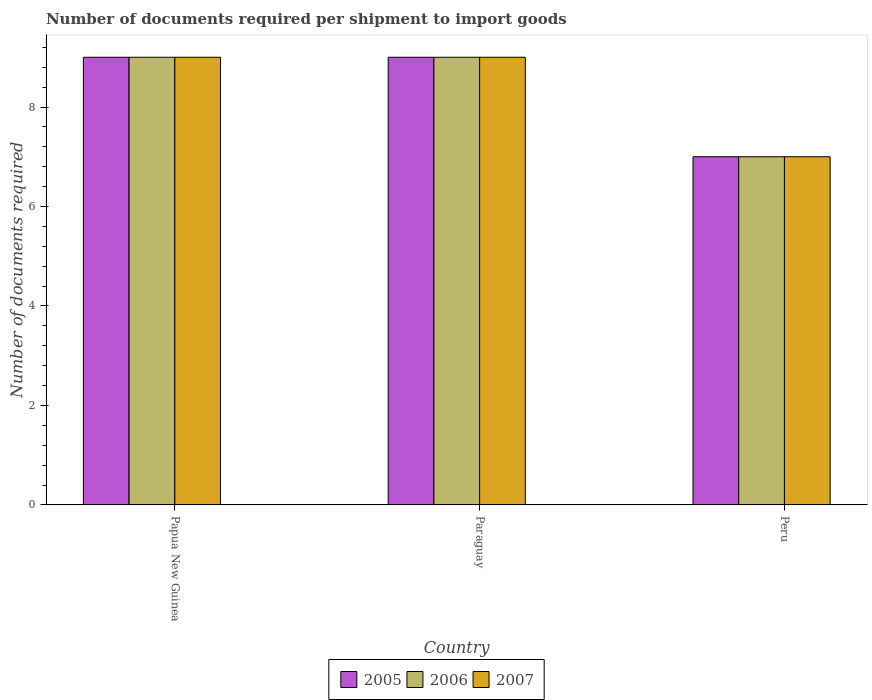Are the number of bars per tick equal to the number of legend labels?
Give a very brief answer. Yes. How many bars are there on the 3rd tick from the left?
Provide a short and direct response. 3. In how many cases, is the number of bars for a given country not equal to the number of legend labels?
Your answer should be very brief. 0. What is the number of documents required per shipment to import goods in 2006 in Papua New Guinea?
Ensure brevity in your answer.  9. Across all countries, what is the maximum number of documents required per shipment to import goods in 2007?
Give a very brief answer. 9. In which country was the number of documents required per shipment to import goods in 2006 maximum?
Make the answer very short. Papua New Guinea. What is the difference between the number of documents required per shipment to import goods in 2007 in Paraguay and that in Peru?
Offer a very short reply. 2. What is the average number of documents required per shipment to import goods in 2006 per country?
Ensure brevity in your answer.  8.33. What is the difference between the number of documents required per shipment to import goods of/in 2006 and number of documents required per shipment to import goods of/in 2007 in Paraguay?
Ensure brevity in your answer.  0. What is the ratio of the number of documents required per shipment to import goods in 2006 in Paraguay to that in Peru?
Provide a short and direct response. 1.29. What is the difference between the highest and the second highest number of documents required per shipment to import goods in 2005?
Keep it short and to the point. 2. What is the difference between the highest and the lowest number of documents required per shipment to import goods in 2007?
Your answer should be compact. 2. What does the 2nd bar from the left in Peru represents?
Your answer should be compact. 2006. What does the 2nd bar from the right in Papua New Guinea represents?
Keep it short and to the point. 2006. Is it the case that in every country, the sum of the number of documents required per shipment to import goods in 2007 and number of documents required per shipment to import goods in 2006 is greater than the number of documents required per shipment to import goods in 2005?
Keep it short and to the point. Yes. How many bars are there?
Provide a short and direct response. 9. How many countries are there in the graph?
Keep it short and to the point. 3. Does the graph contain any zero values?
Keep it short and to the point. No. Does the graph contain grids?
Your response must be concise. No. What is the title of the graph?
Ensure brevity in your answer.  Number of documents required per shipment to import goods. Does "1984" appear as one of the legend labels in the graph?
Your response must be concise. No. What is the label or title of the X-axis?
Make the answer very short. Country. What is the label or title of the Y-axis?
Your response must be concise. Number of documents required. What is the Number of documents required in 2006 in Paraguay?
Your answer should be very brief. 9. What is the Number of documents required in 2007 in Paraguay?
Your answer should be very brief. 9. What is the Number of documents required in 2005 in Peru?
Keep it short and to the point. 7. What is the Number of documents required of 2006 in Peru?
Your answer should be compact. 7. Across all countries, what is the maximum Number of documents required in 2005?
Keep it short and to the point. 9. Across all countries, what is the maximum Number of documents required in 2006?
Offer a terse response. 9. Across all countries, what is the maximum Number of documents required of 2007?
Keep it short and to the point. 9. Across all countries, what is the minimum Number of documents required of 2005?
Keep it short and to the point. 7. What is the total Number of documents required in 2005 in the graph?
Your answer should be compact. 25. What is the total Number of documents required in 2006 in the graph?
Your answer should be compact. 25. What is the difference between the Number of documents required of 2005 in Papua New Guinea and that in Paraguay?
Ensure brevity in your answer.  0. What is the difference between the Number of documents required in 2007 in Papua New Guinea and that in Paraguay?
Provide a succinct answer. 0. What is the difference between the Number of documents required in 2005 in Papua New Guinea and that in Peru?
Your answer should be very brief. 2. What is the difference between the Number of documents required in 2007 in Papua New Guinea and that in Peru?
Offer a terse response. 2. What is the difference between the Number of documents required of 2005 in Papua New Guinea and the Number of documents required of 2006 in Paraguay?
Ensure brevity in your answer.  0. What is the difference between the Number of documents required of 2006 in Papua New Guinea and the Number of documents required of 2007 in Paraguay?
Keep it short and to the point. 0. What is the difference between the Number of documents required in 2005 in Papua New Guinea and the Number of documents required in 2006 in Peru?
Your answer should be very brief. 2. What is the difference between the Number of documents required of 2005 in Papua New Guinea and the Number of documents required of 2007 in Peru?
Offer a very short reply. 2. What is the difference between the Number of documents required in 2006 in Papua New Guinea and the Number of documents required in 2007 in Peru?
Provide a short and direct response. 2. What is the average Number of documents required of 2005 per country?
Ensure brevity in your answer.  8.33. What is the average Number of documents required in 2006 per country?
Your answer should be very brief. 8.33. What is the average Number of documents required of 2007 per country?
Your answer should be very brief. 8.33. What is the difference between the Number of documents required in 2005 and Number of documents required in 2006 in Papua New Guinea?
Keep it short and to the point. 0. What is the difference between the Number of documents required in 2005 and Number of documents required in 2007 in Papua New Guinea?
Provide a succinct answer. 0. What is the difference between the Number of documents required of 2005 and Number of documents required of 2006 in Paraguay?
Ensure brevity in your answer.  0. What is the difference between the Number of documents required of 2005 and Number of documents required of 2007 in Paraguay?
Your response must be concise. 0. What is the difference between the Number of documents required in 2006 and Number of documents required in 2007 in Paraguay?
Give a very brief answer. 0. What is the difference between the Number of documents required of 2006 and Number of documents required of 2007 in Peru?
Make the answer very short. 0. What is the ratio of the Number of documents required of 2006 in Papua New Guinea to that in Paraguay?
Offer a very short reply. 1. What is the ratio of the Number of documents required in 2005 in Papua New Guinea to that in Peru?
Make the answer very short. 1.29. What is the ratio of the Number of documents required of 2005 in Paraguay to that in Peru?
Keep it short and to the point. 1.29. What is the ratio of the Number of documents required of 2006 in Paraguay to that in Peru?
Offer a terse response. 1.29. What is the difference between the highest and the second highest Number of documents required of 2005?
Provide a short and direct response. 0. What is the difference between the highest and the second highest Number of documents required of 2006?
Make the answer very short. 0. What is the difference between the highest and the lowest Number of documents required of 2005?
Offer a very short reply. 2. What is the difference between the highest and the lowest Number of documents required in 2006?
Offer a terse response. 2. What is the difference between the highest and the lowest Number of documents required of 2007?
Provide a succinct answer. 2. 